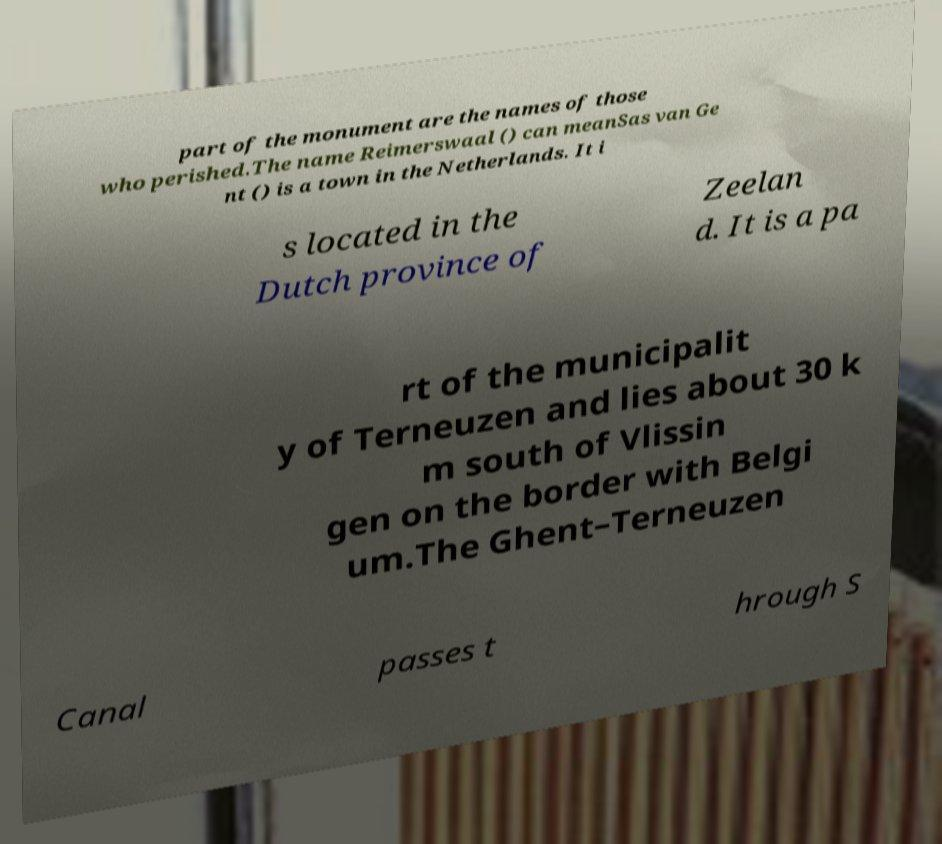Please identify and transcribe the text found in this image. part of the monument are the names of those who perished.The name Reimerswaal () can meanSas van Ge nt () is a town in the Netherlands. It i s located in the Dutch province of Zeelan d. It is a pa rt of the municipalit y of Terneuzen and lies about 30 k m south of Vlissin gen on the border with Belgi um.The Ghent–Terneuzen Canal passes t hrough S 